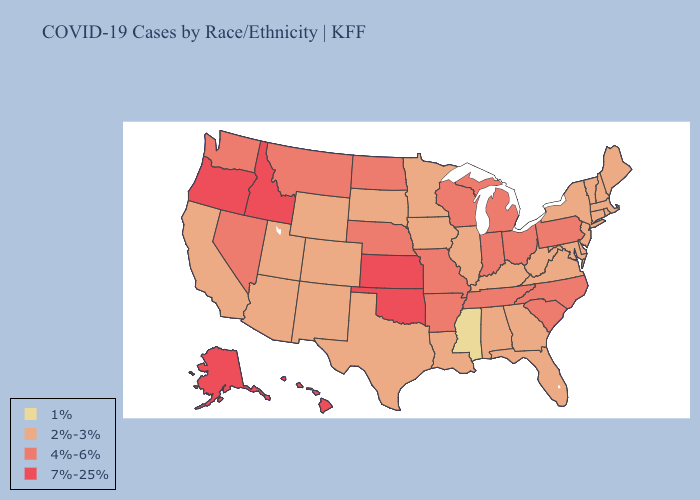What is the highest value in the USA?
Short answer required. 7%-25%. Among the states that border Kentucky , does Tennessee have the lowest value?
Be succinct. No. Does New Hampshire have a lower value than Texas?
Concise answer only. No. What is the lowest value in the Northeast?
Short answer required. 2%-3%. What is the highest value in the West ?
Keep it brief. 7%-25%. Does the map have missing data?
Write a very short answer. No. Does Missouri have the lowest value in the USA?
Write a very short answer. No. Does Virginia have the same value as Massachusetts?
Keep it brief. Yes. Which states have the lowest value in the USA?
Quick response, please. Mississippi. What is the value of Alabama?
Give a very brief answer. 2%-3%. Which states have the lowest value in the USA?
Quick response, please. Mississippi. What is the lowest value in the MidWest?
Write a very short answer. 2%-3%. Does Wyoming have the highest value in the USA?
Short answer required. No. What is the lowest value in the South?
Keep it brief. 1%. Does the map have missing data?
Quick response, please. No. 